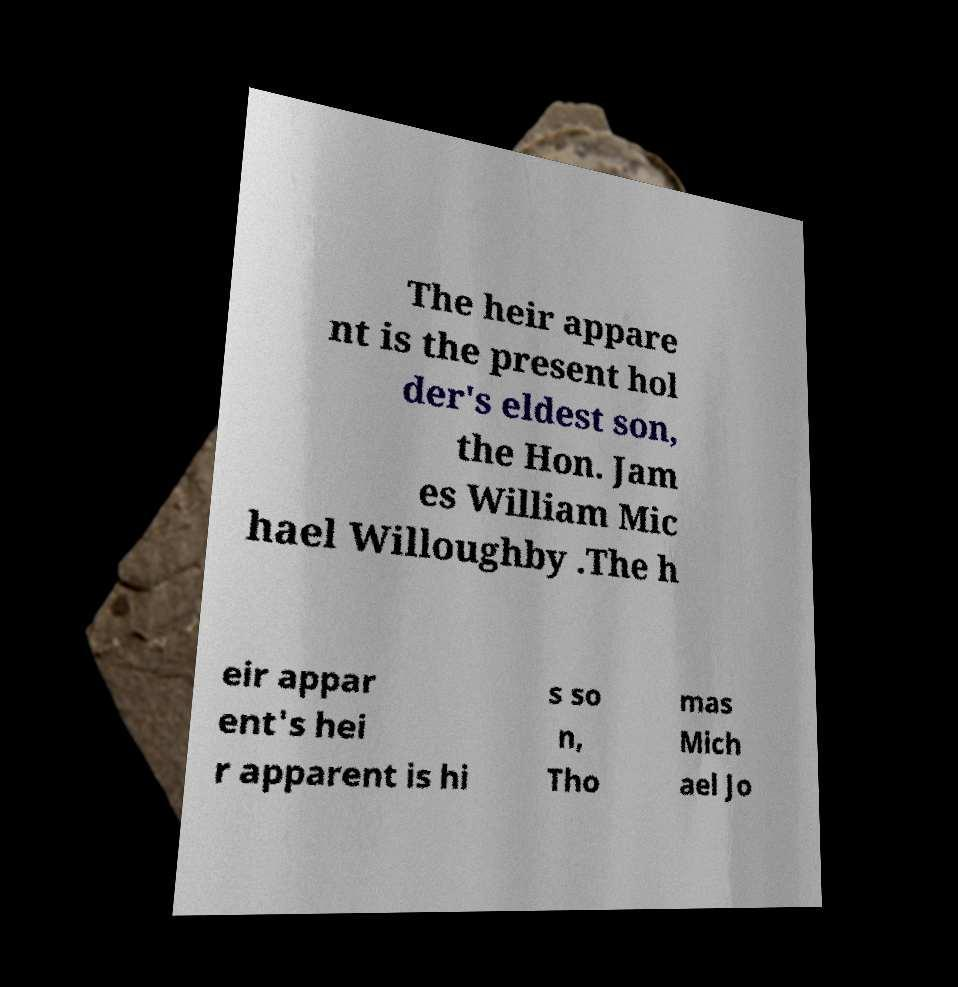Please read and relay the text visible in this image. What does it say? The heir appare nt is the present hol der's eldest son, the Hon. Jam es William Mic hael Willoughby .The h eir appar ent's hei r apparent is hi s so n, Tho mas Mich ael Jo 